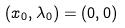<formula> <loc_0><loc_0><loc_500><loc_500>( x _ { 0 } , \lambda _ { 0 } ) = ( 0 , 0 )</formula> 